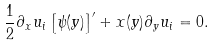Convert formula to latex. <formula><loc_0><loc_0><loc_500><loc_500>\frac { 1 } { 2 } \partial _ { x } u _ { i } \left [ \psi ( y ) \right ] ^ { \prime } + x ( y ) \partial _ { y } u _ { i } = 0 .</formula> 